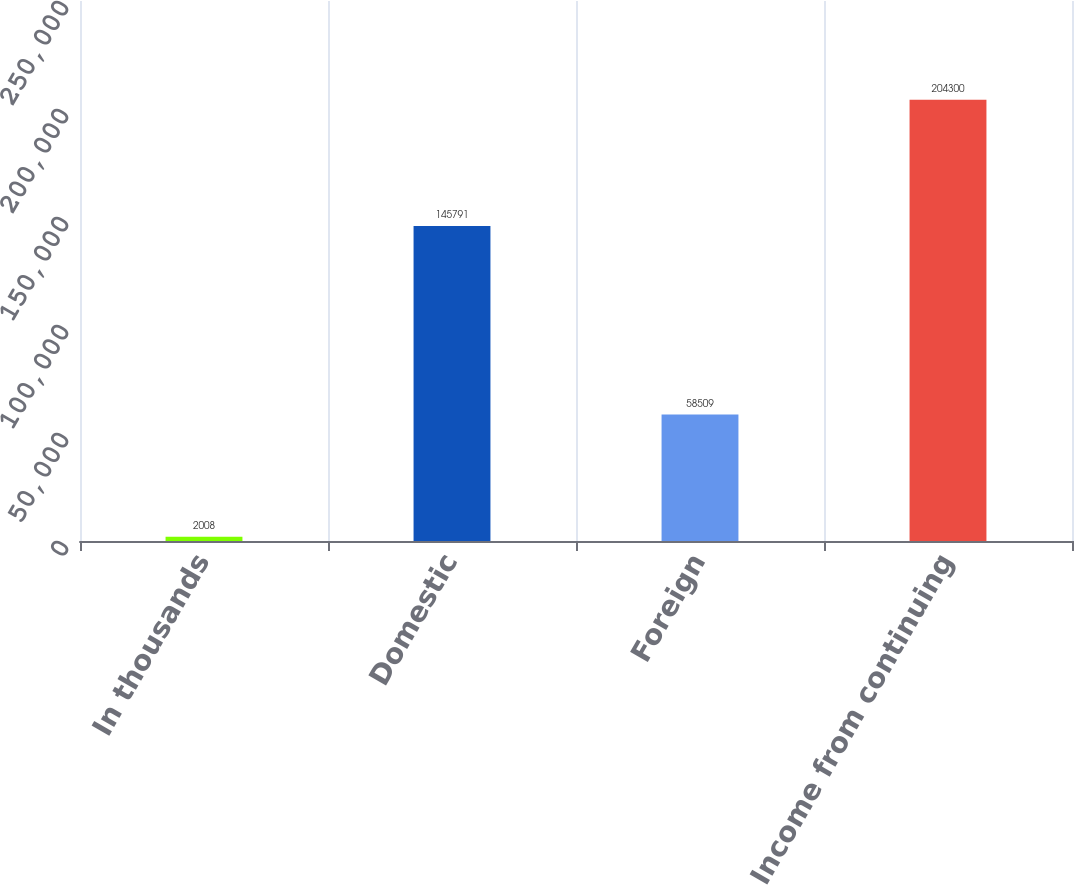Convert chart. <chart><loc_0><loc_0><loc_500><loc_500><bar_chart><fcel>In thousands<fcel>Domestic<fcel>Foreign<fcel>Income from continuing<nl><fcel>2008<fcel>145791<fcel>58509<fcel>204300<nl></chart> 